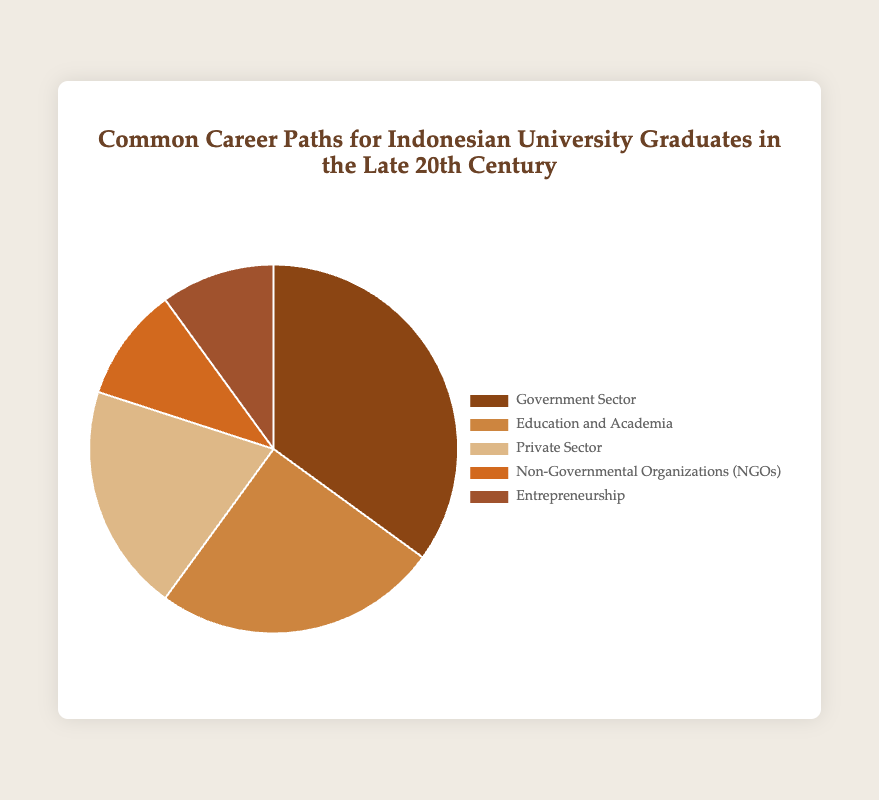What is the most common career path for Indonesian university graduates in the late 20th century? The largest section of the pie chart represents the Government Sector, indicating it’s the most common career path.
Answer: Government Sector What percentage of graduates went into Education and Academia? The pie chart shows that the section labeled "Education and Academia" represents 25% of the total.
Answer: 25% How does the percentage of graduates in the Government Sector compare to those in the Private Sector? The Government Sector has 35% while the Private Sector has 20%. 35% is greater than 20%.
Answer: Government Sector has a higher percentage What are the total percentages for the sum of those employed in the NGO and Entrepreneurship sectors? Adding the percentages for NGOs (10%) and Entrepreneurship (10%) gives a total of 20%.
Answer: 20% What is the difference in percentage between those employed in the Government Sector and the Private Sector? The Government Sector has 35% and the Private Sector has 20%. The difference is 35% - 20% = 15%.
Answer: 15% Which sector has the smallest representation among graduates? Both the Non-Governmental Organizations (NGOs) and Entrepreneurship sectors are the smallest, each with 10%.
Answer: NGOs and Entrepreneurship How much more popular is the Government Sector compared to Education and Academia? The Government Sector has 35% and Education and Academia has 25%. The difference is 35% - 25% = 10%.
Answer: 10% more popular If you combine the percentages of graduates in Education and Academia, and the Private Sector, does the total exceed that of the Government Sector? The percentages for Education and Academia (25%) and the Private Sector (20%) sum to 45%. This is more than the Government Sector's 35%.
Answer: Yes What is the visual representation color for the Entrepreneurship sector in the pie chart? The pie chart uses a brown color scheme, with the sector for Entrepreneurship represented in a lighter brown shade.
Answer: Lighter brown shade Which three sectors combined make up exactly half of the total percentage shown in the pie chart? Adding the percentages for Private Sector (20%), NGOs (10%), and Entrepreneurship (10%) results in 40%. These three sectors together do not make up half of the pie. Instead, trying Government Sector (35%) and NGOs (10%) gives 45%, close to half.
Answer: No exact combination makes up exactly half 